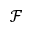<formula> <loc_0><loc_0><loc_500><loc_500>\mathcal { F }</formula> 